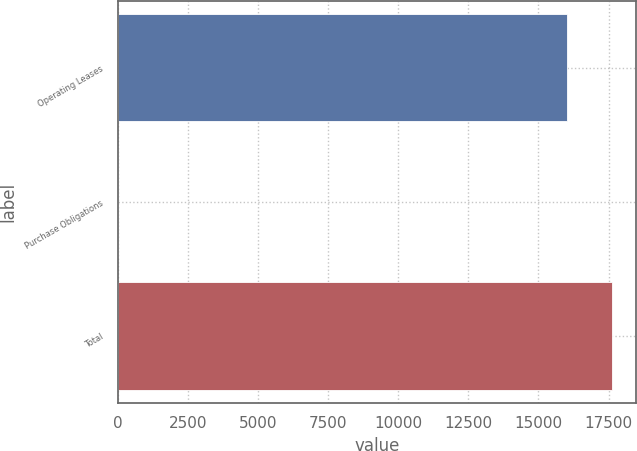Convert chart. <chart><loc_0><loc_0><loc_500><loc_500><bar_chart><fcel>Operating Leases<fcel>Purchase Obligations<fcel>Total<nl><fcel>16012<fcel>1.64<fcel>17613<nl></chart> 